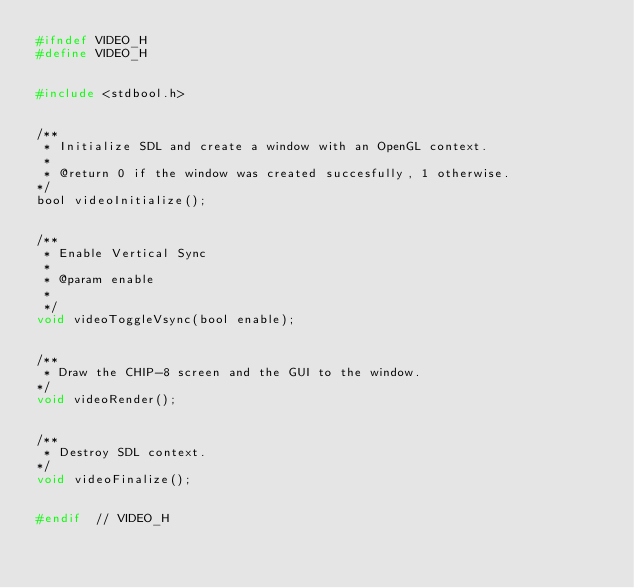<code> <loc_0><loc_0><loc_500><loc_500><_C_>#ifndef VIDEO_H
#define VIDEO_H


#include <stdbool.h>


/**
 * Initialize SDL and create a window with an OpenGL context.
 *
 * @return 0 if the window was created succesfully, 1 otherwise.
*/
bool videoInitialize();


/**
 * Enable Vertical Sync
 *
 * @param enable
 *
 */
void videoToggleVsync(bool enable);


/**
 * Draw the CHIP-8 screen and the GUI to the window.
*/
void videoRender();


/**
 * Destroy SDL context.
*/
void videoFinalize();


#endif  // VIDEO_H
</code> 